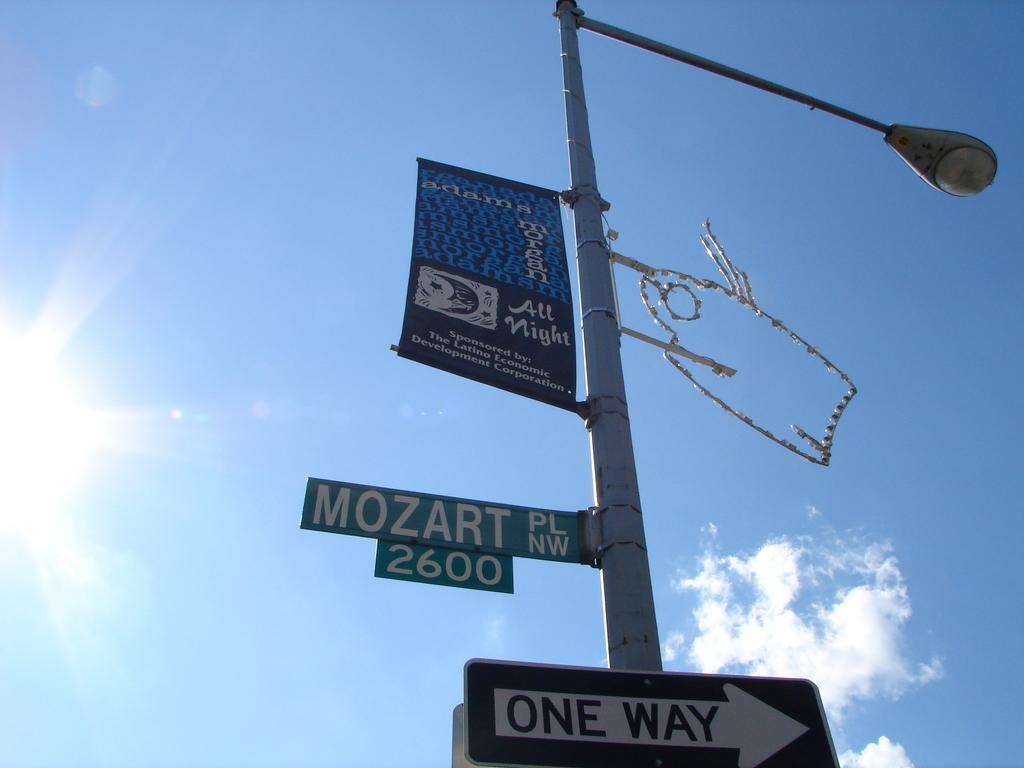What is the name of the street?
Ensure brevity in your answer.  Mozart. Which way can i go?
Keep it short and to the point. One way. 